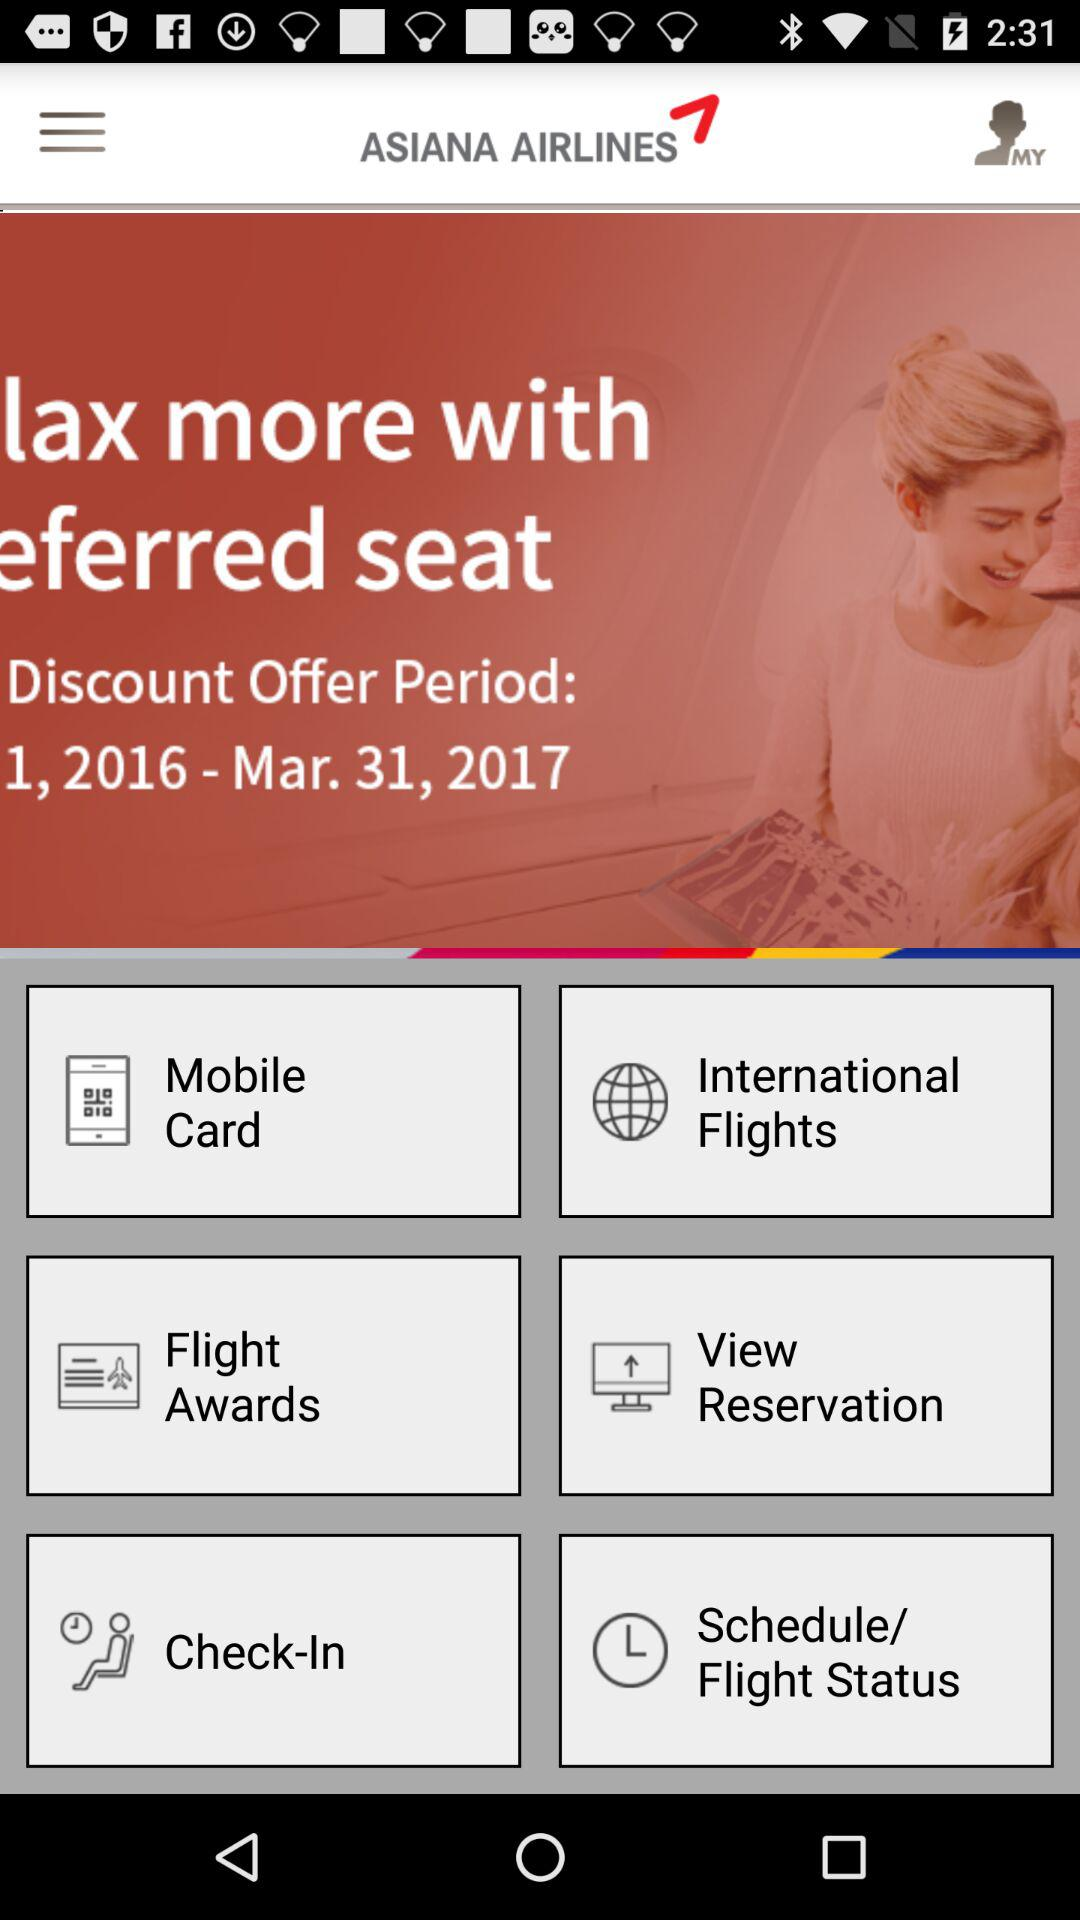When does the discount offer period end? The discount offer period ends on March 31, 2017. 